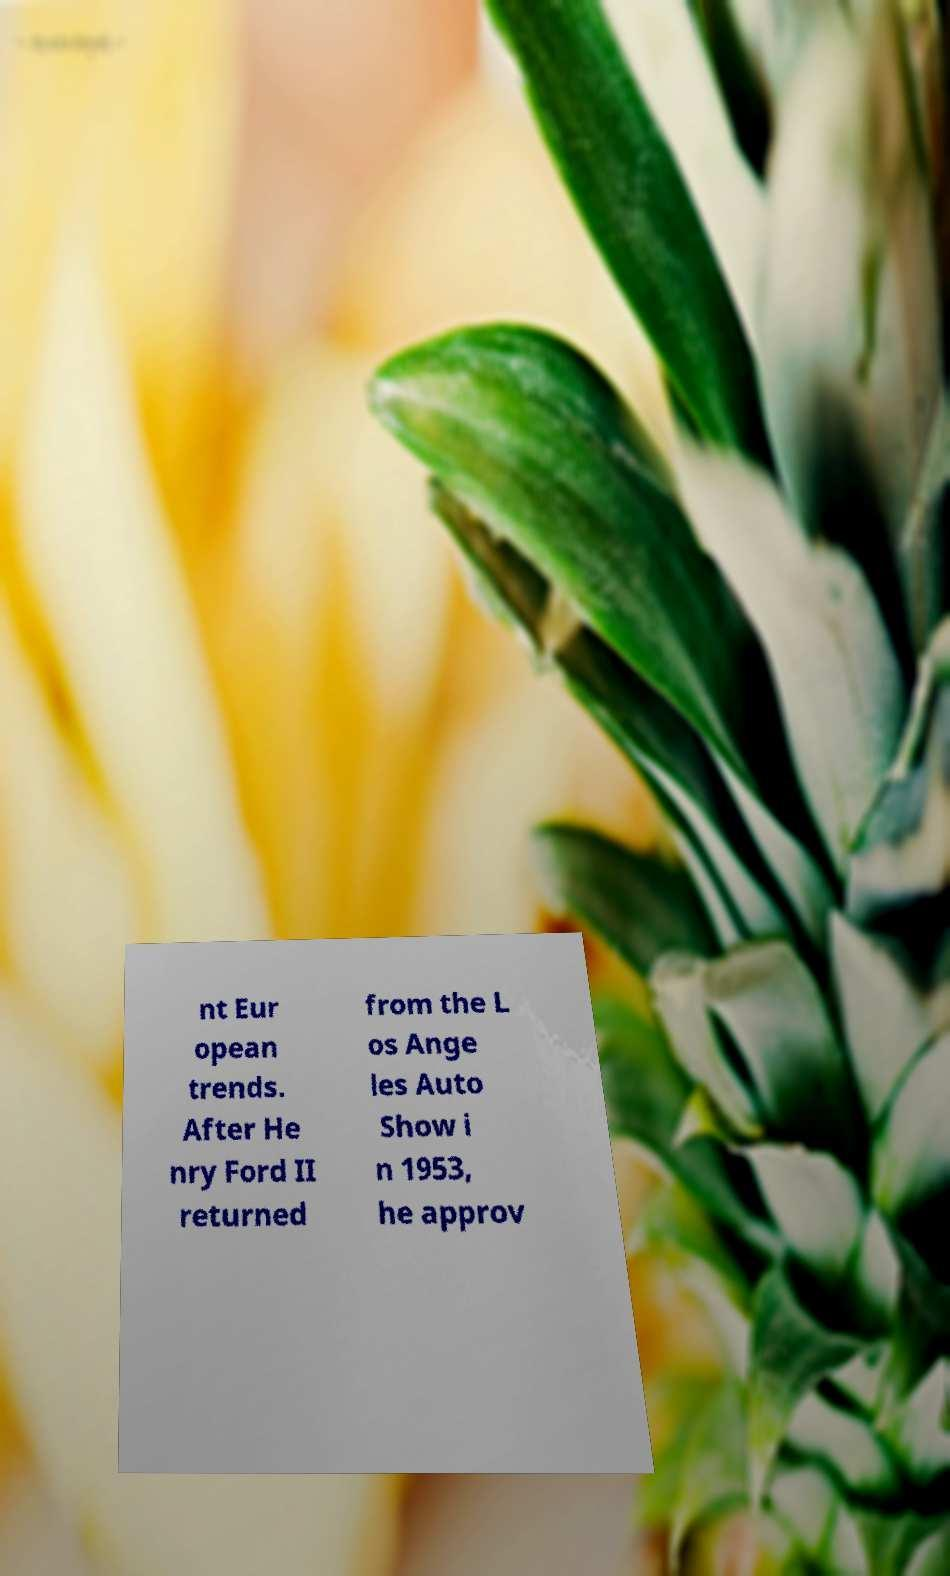I need the written content from this picture converted into text. Can you do that? nt Eur opean trends. After He nry Ford II returned from the L os Ange les Auto Show i n 1953, he approv 